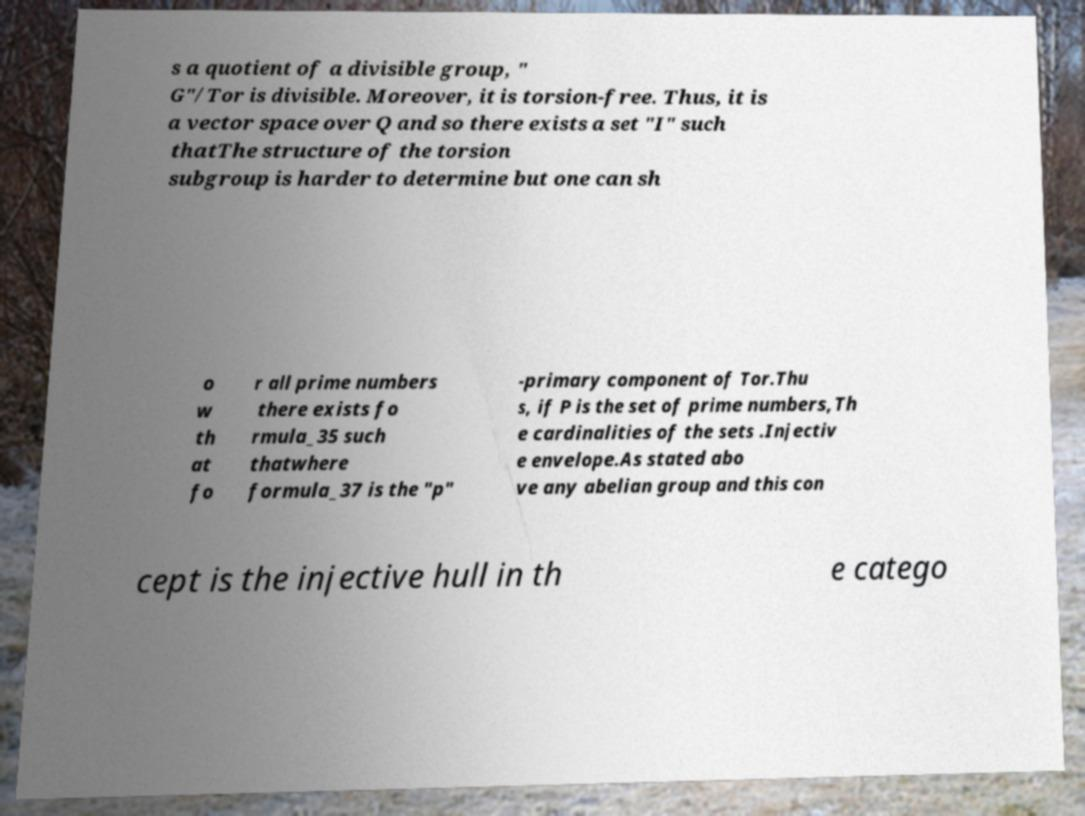Can you accurately transcribe the text from the provided image for me? s a quotient of a divisible group, " G"/Tor is divisible. Moreover, it is torsion-free. Thus, it is a vector space over Q and so there exists a set "I" such thatThe structure of the torsion subgroup is harder to determine but one can sh o w th at fo r all prime numbers there exists fo rmula_35 such thatwhere formula_37 is the "p" -primary component of Tor.Thu s, if P is the set of prime numbers,Th e cardinalities of the sets .Injectiv e envelope.As stated abo ve any abelian group and this con cept is the injective hull in th e catego 